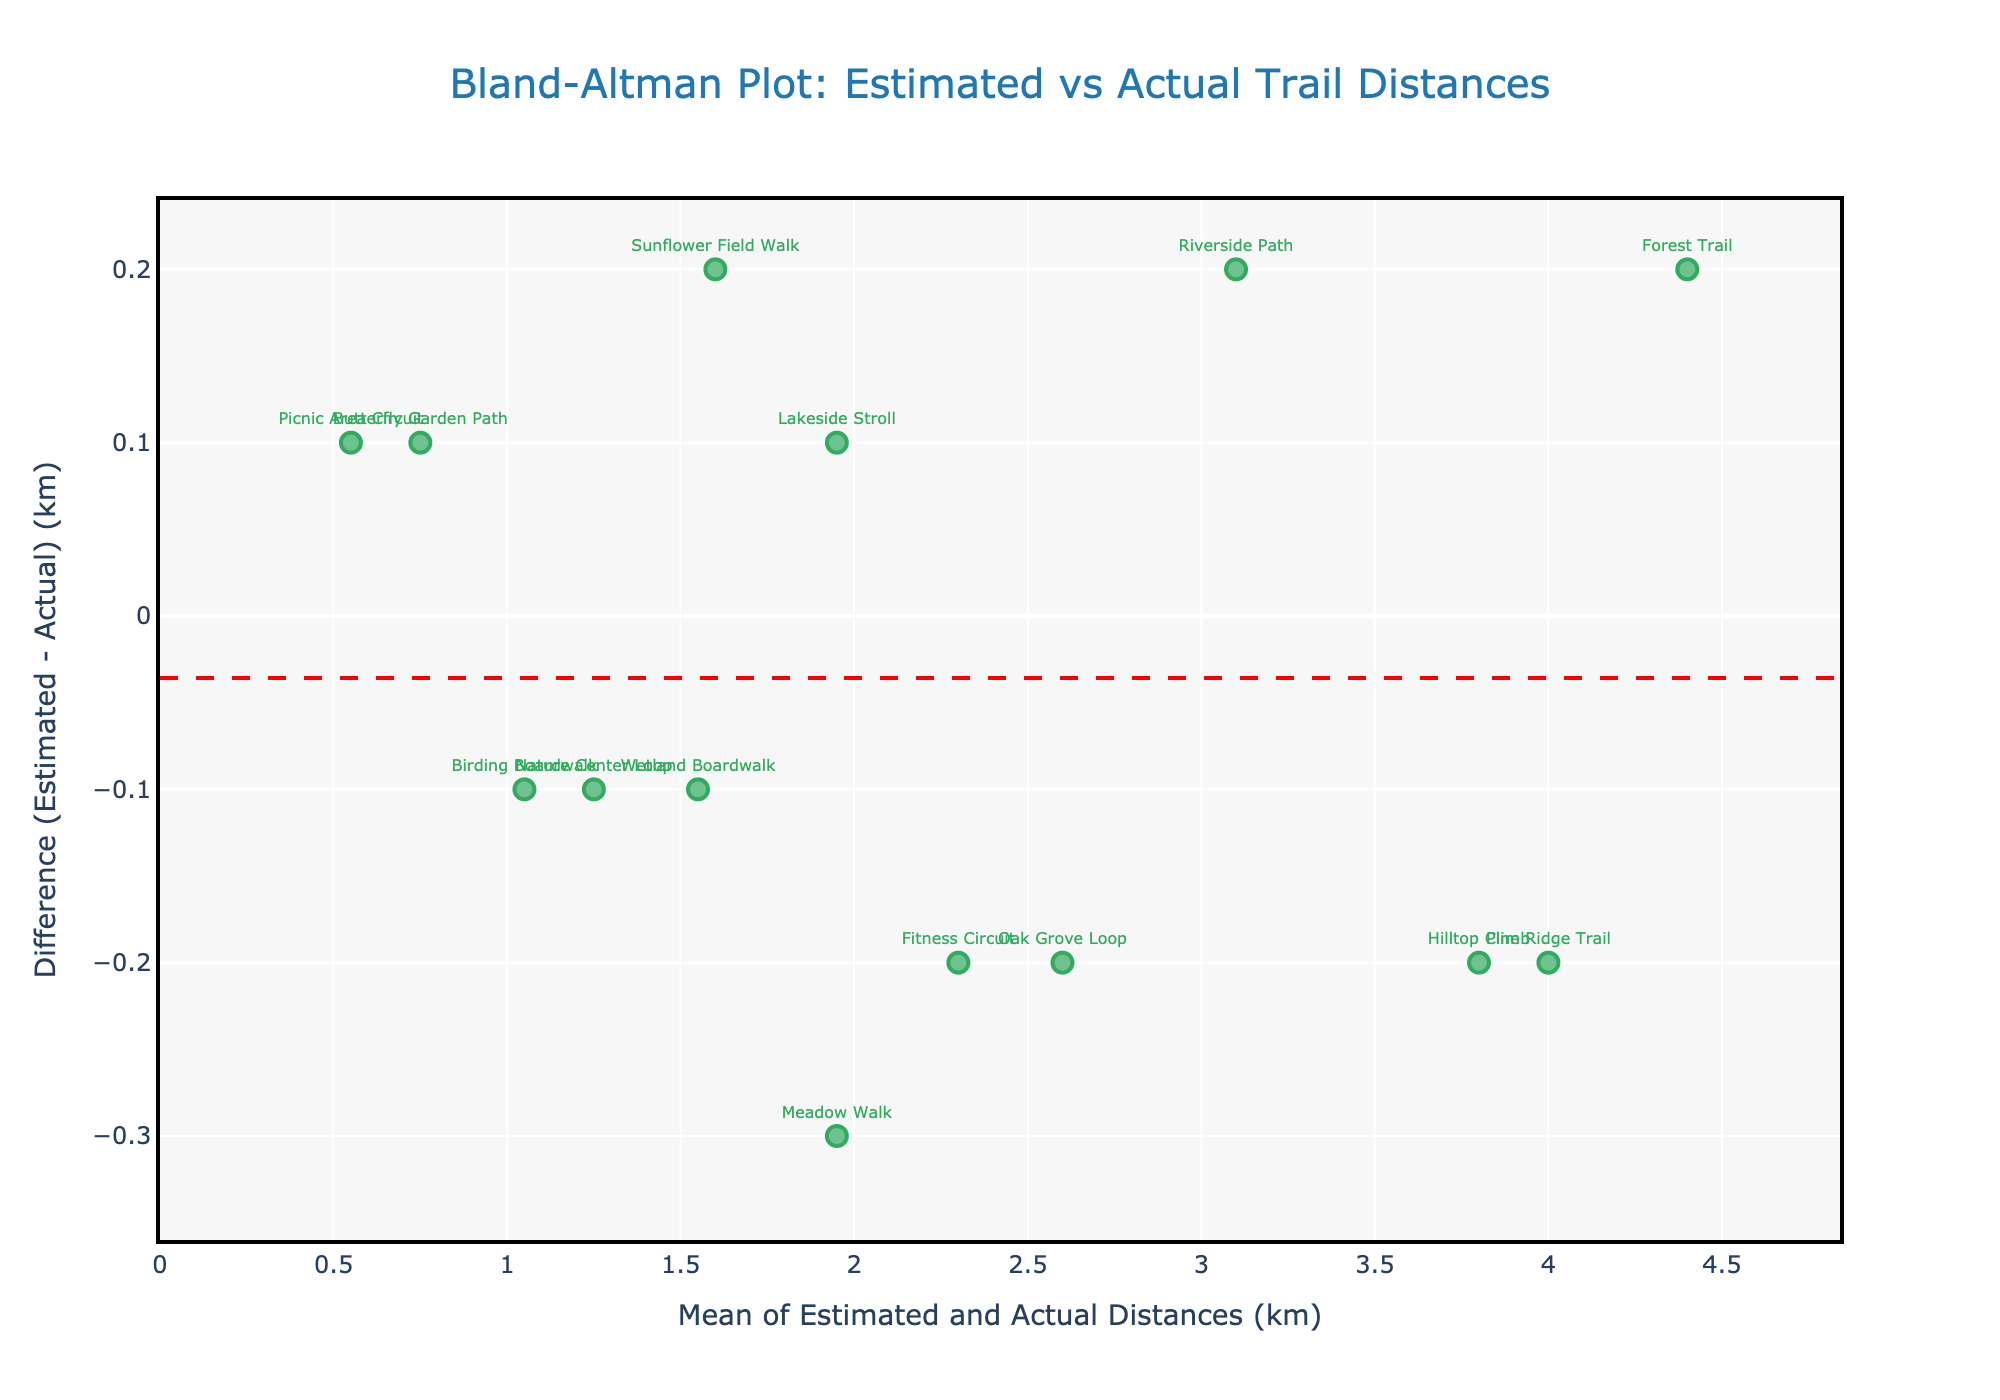What is the title of the plot? The title of the plot is displayed at the top in larger and darker-colored text. It reads "Bland-Altman Plot: Estimated vs Actual Trail Distances."
Answer: Bland-Altman Plot: Estimated vs Actual Trail Distances What does the y-axis represent? The y-axis label, located vertically on the left side of the plot, indicates it represents the "Difference (Estimated - Actual) (km)."
Answer: Difference (Estimated - Actual) (km) Which trail has the largest estimation error? By identifying the data point with the highest absolute difference from 0 on the y-axis, we can see that the "Meadow Walk" trail has the largest estimation error.
Answer: Meadow Walk What are the lower and upper limits of agreement for the differences? The lower limit of agreement is marked by a dotted blue line near the lower end of the y-axis, and the upper limit of agreement is marked by another dotted blue line near the upper end of the y-axis. Specifically, these values are around -0.36 and 0.36, respectively.
Answer: -0.36 and 0.36 What is the mean difference between the estimated and actual distances? The red dashed line on the plot corresponds to the mean difference between the estimated and actual distances. This line is slightly above the zero line, reflecting a mean difference close to zero but slightly positive.
Answer: Approximately 0.01 km How many trails have an overestimation of the distance? Overestimation corresponds to the data points above the zero line (y>0) on the plot. By counting them, we find that there are 7 trails where visitors overestimated the distance.
Answer: 7 trails Which trail's distance was underestimated the most? The lowest point on the y-axis indicates the greatest underestimation. The "Sunflower Field Walk" has the largest negative difference, indicating the most underestimation.
Answer: Sunflower Field Walk How many trails fall within the limits of agreement? The limits of agreement are shown as dotted blue lines on the plot. By counting the data points that fall between these two lines, we find there are 13 trails within the limits of agreement.
Answer: 13 trails What is the mean of the estimated and actual distances for the "Hilltop Climb" trail? To find the mean of the estimated and actual distances for a specific trail, we use the formula: (Estimated + Actual) / 2. For "Hilltop Climb," the values are 3.7 km and 3.9 km respectively. Thus, the mean is (3.7 + 3.9) / 2 = 3.8 km.
Answer: 3.8 km Which trail has the closest estimation to the actual distance? The data point that is closest to the zero line (y=0) on the plot indicates the closest estimation to the actual distance. "Lakeside Stroll" has the smallest difference, indicating the closest estimation.
Answer: Lakeside Stroll 